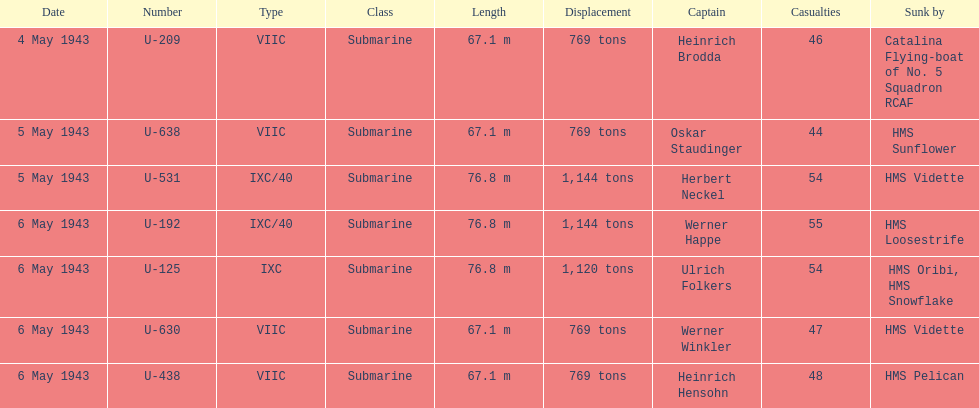Which ship sunk the most u-boats HMS Vidette. Parse the table in full. {'header': ['Date', 'Number', 'Type', 'Class', 'Length', 'Displacement', 'Captain', 'Casualties', 'Sunk by'], 'rows': [['4 May 1943', 'U-209', 'VIIC', 'Submarine', '67.1 m', '769 tons', 'Heinrich Brodda', '46', 'Catalina Flying-boat of No. 5 Squadron RCAF'], ['5 May 1943', 'U-638', 'VIIC', 'Submarine', '67.1 m', '769 tons', 'Oskar Staudinger', '44', 'HMS Sunflower'], ['5 May 1943', 'U-531', 'IXC/40', 'Submarine', '76.8 m', '1,144 tons', 'Herbert Neckel', '54', 'HMS Vidette'], ['6 May 1943', 'U-192', 'IXC/40', 'Submarine', '76.8 m', '1,144 tons', 'Werner Happe', '55', 'HMS Loosestrife'], ['6 May 1943', 'U-125', 'IXC', 'Submarine', '76.8 m', '1,120 tons', 'Ulrich Folkers', '54', 'HMS Oribi, HMS Snowflake'], ['6 May 1943', 'U-630', 'VIIC', 'Submarine', '67.1 m', '769 tons', 'Werner Winkler', '47', 'HMS Vidette'], ['6 May 1943', 'U-438', 'VIIC', 'Submarine', '67.1 m', '769 tons', 'Heinrich Hensohn', '48', 'HMS Pelican']]} 